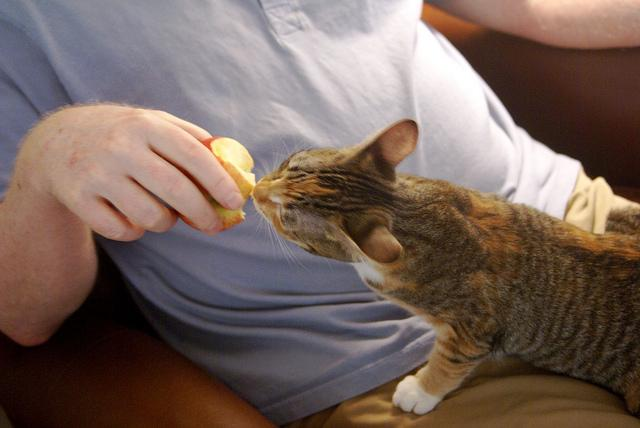Where do apples originate from? asia 